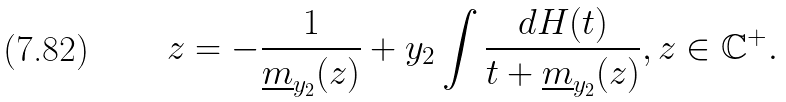<formula> <loc_0><loc_0><loc_500><loc_500>z = - \frac { 1 } { \underline { m } _ { y _ { 2 } } ( z ) } + y _ { 2 } \int \frac { d H ( t ) } { t + \underline { m } _ { y _ { 2 } } ( z ) } , z \in \mathbb { C } ^ { + } .</formula> 